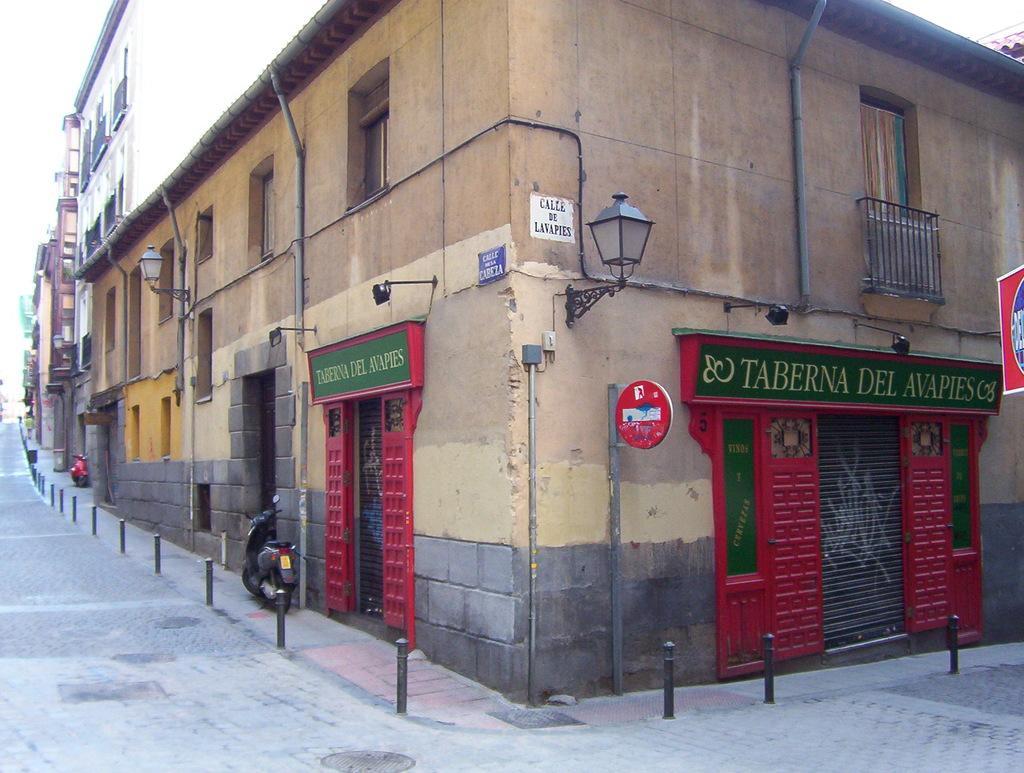Could you give a brief overview of what you see in this image? In this image I can see two vehicles on the road. I can also see building in brown color, sky in white color. In front I can see two stalls and the door is in red color, I can also see green color board attached to the wall. 